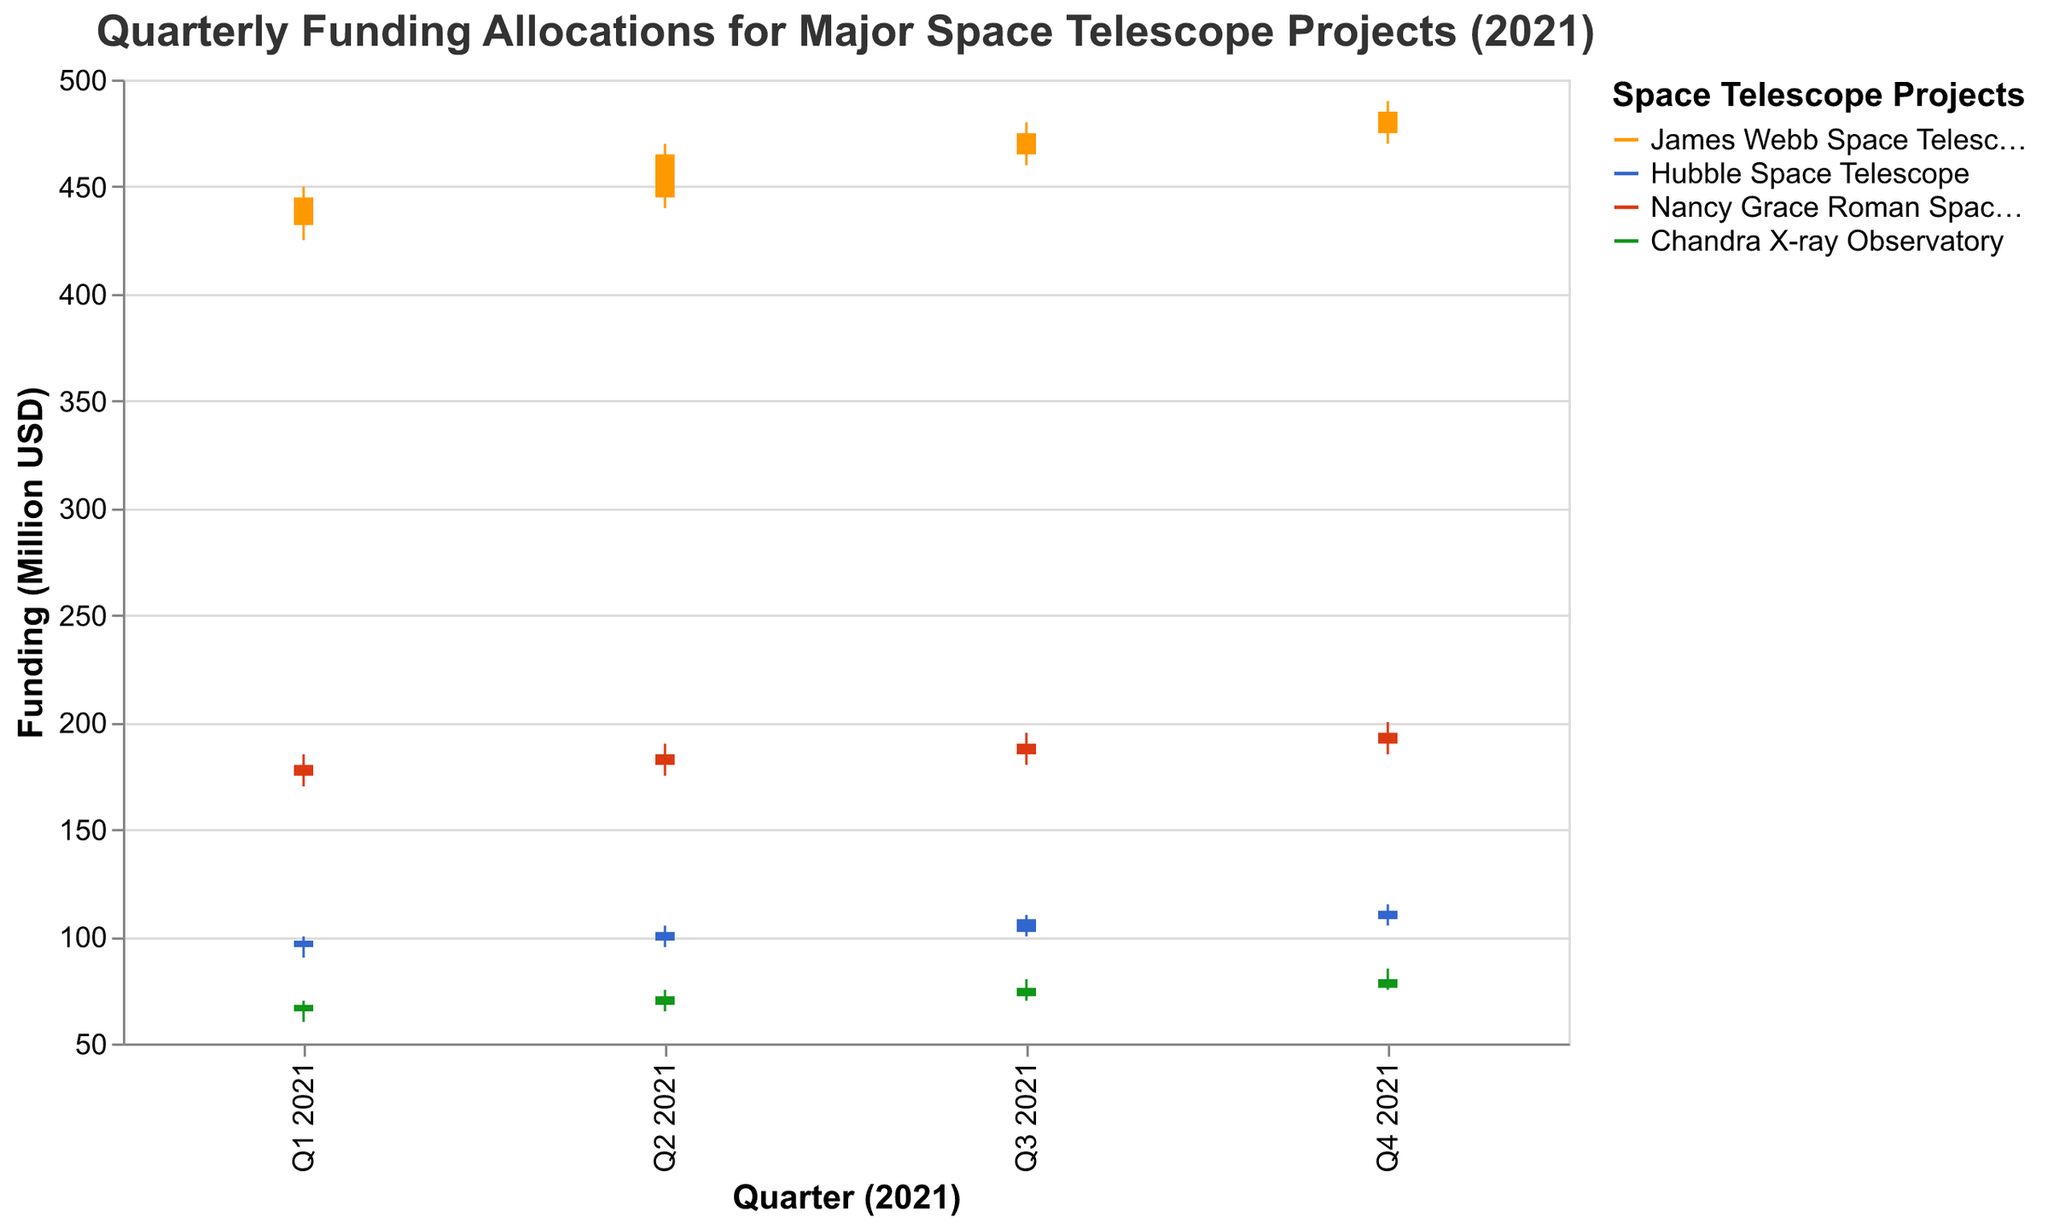Which project received the highest funding in Q1 2021? The figure shows that the James Webb Space Telescope received the highest funding during Q1 2021, indicated by the highest values on the vertical axis for this period.
Answer: James Webb Space Telescope How did the funding for the Hubble Space Telescope change from Q1 to Q4 in 2021? The figure's OHLC chart shows the funding for Hubble increasing from an open of 95 million USD in Q1 2021 to a close of 112 million USD in Q4 2021.
Answer: It increased What is the largest range between the high and low values across all projects in any quarter? The largest range can be found by looking at the difference between the high and low values for each project over each quarter. The Chandra X-ray Observatory in Q4 has the largest range, 85 - 75 = 15 million USD.
Answer: 15 million USD Which project had the smallest increase in its closing funding value from Q1 to Q4 2021? By comparing the closing values reported for each quarter, we see the smallest increase from Q1 to Q4 for the Chandra X-ray Observatory, increasing from 68 million USD to 80 million USD.
Answer: Chandra X-ray Observatory During which quarter did the Nancy Grace Roman Space Telescope have the highest high funding? By checking the High values for each quarter for the Nancy Grace Roman Space Telescope, the highest high is 200 million USD in Q4 2021.
Answer: Q4 2021 Is there any project that shows a consistent upward trend in funding over the year 2021? By examining the Close values for each quarter, the James Webb Space Telescope displays a consistent upward trend with increased closing values each quarter.
Answer: James Webb Space Telescope What was the opening funding for the Chandra X-ray Observatory in Q3 2021, and how did it compare to its closing funding in Q2 2021? The opening funding for the Chandra X-ray Observatory in Q3 2021 was 72 million USD, and the closing funding in Q2 2021 was 72 million USD. They are equal.
Answer: 72 million USD, equal Which project had the highest closing funding value in Q2 2021? By checking the Close values for Q2 2021, the James Webb Space Telescope had the highest closing funding value of 465 million USD.
Answer: James Webb Space Telescope 